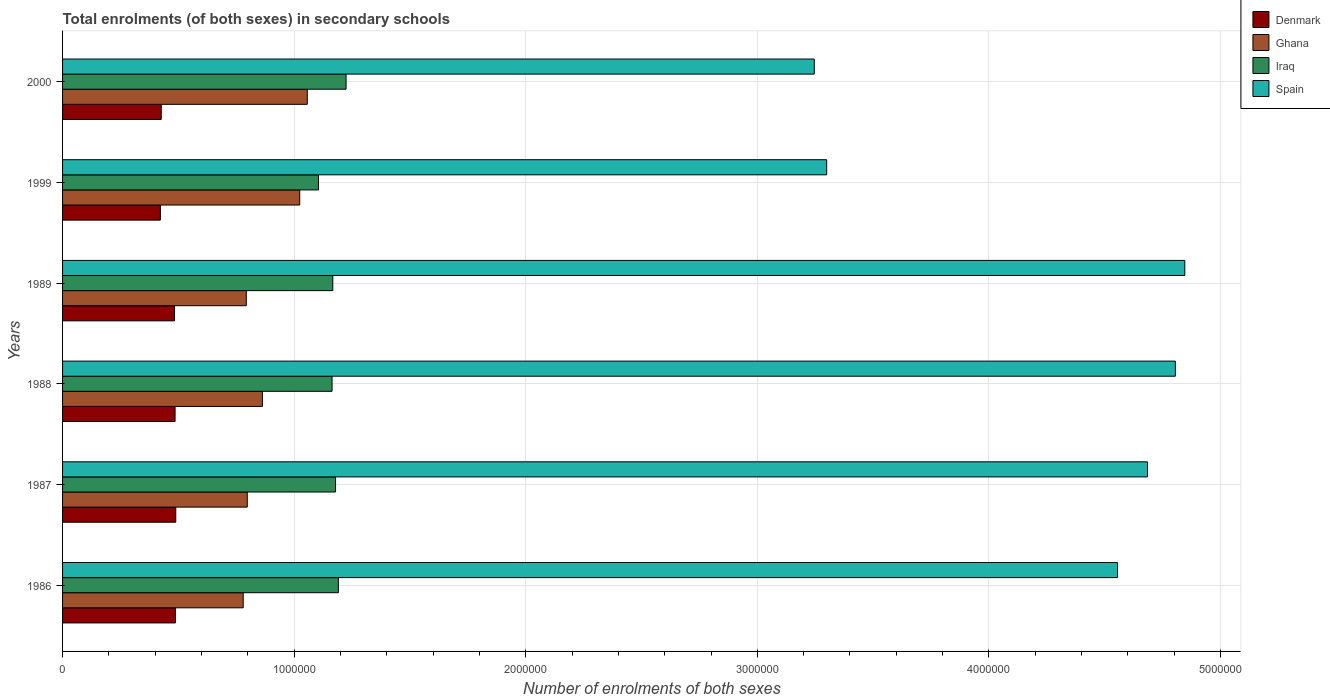Are the number of bars per tick equal to the number of legend labels?
Your answer should be compact. Yes. Are the number of bars on each tick of the Y-axis equal?
Offer a very short reply. Yes. In how many cases, is the number of bars for a given year not equal to the number of legend labels?
Offer a very short reply. 0. What is the number of enrolments in secondary schools in Iraq in 1987?
Keep it short and to the point. 1.18e+06. Across all years, what is the maximum number of enrolments in secondary schools in Spain?
Offer a very short reply. 4.85e+06. Across all years, what is the minimum number of enrolments in secondary schools in Denmark?
Offer a terse response. 4.22e+05. In which year was the number of enrolments in secondary schools in Denmark minimum?
Ensure brevity in your answer.  1999. What is the total number of enrolments in secondary schools in Iraq in the graph?
Ensure brevity in your answer.  7.03e+06. What is the difference between the number of enrolments in secondary schools in Iraq in 1986 and that in 1999?
Keep it short and to the point. 8.58e+04. What is the difference between the number of enrolments in secondary schools in Iraq in 1988 and the number of enrolments in secondary schools in Spain in 1989?
Offer a terse response. -3.68e+06. What is the average number of enrolments in secondary schools in Denmark per year?
Your response must be concise. 4.66e+05. In the year 1989, what is the difference between the number of enrolments in secondary schools in Denmark and number of enrolments in secondary schools in Iraq?
Make the answer very short. -6.83e+05. What is the ratio of the number of enrolments in secondary schools in Iraq in 1986 to that in 2000?
Provide a short and direct response. 0.97. Is the number of enrolments in secondary schools in Ghana in 1988 less than that in 1989?
Provide a succinct answer. No. What is the difference between the highest and the second highest number of enrolments in secondary schools in Spain?
Provide a short and direct response. 4.08e+04. What is the difference between the highest and the lowest number of enrolments in secondary schools in Ghana?
Give a very brief answer. 2.77e+05. In how many years, is the number of enrolments in secondary schools in Ghana greater than the average number of enrolments in secondary schools in Ghana taken over all years?
Ensure brevity in your answer.  2. Is the sum of the number of enrolments in secondary schools in Ghana in 1987 and 1988 greater than the maximum number of enrolments in secondary schools in Spain across all years?
Keep it short and to the point. No. Is it the case that in every year, the sum of the number of enrolments in secondary schools in Spain and number of enrolments in secondary schools in Ghana is greater than the sum of number of enrolments in secondary schools in Iraq and number of enrolments in secondary schools in Denmark?
Ensure brevity in your answer.  Yes. What does the 1st bar from the top in 1987 represents?
Make the answer very short. Spain. Is it the case that in every year, the sum of the number of enrolments in secondary schools in Denmark and number of enrolments in secondary schools in Iraq is greater than the number of enrolments in secondary schools in Spain?
Give a very brief answer. No. How many bars are there?
Give a very brief answer. 24. Are all the bars in the graph horizontal?
Provide a succinct answer. Yes. How many years are there in the graph?
Your answer should be very brief. 6. What is the difference between two consecutive major ticks on the X-axis?
Provide a short and direct response. 1.00e+06. Are the values on the major ticks of X-axis written in scientific E-notation?
Give a very brief answer. No. Does the graph contain grids?
Provide a short and direct response. Yes. What is the title of the graph?
Give a very brief answer. Total enrolments (of both sexes) in secondary schools. Does "East Asia (all income levels)" appear as one of the legend labels in the graph?
Offer a terse response. No. What is the label or title of the X-axis?
Give a very brief answer. Number of enrolments of both sexes. What is the Number of enrolments of both sexes of Denmark in 1986?
Offer a terse response. 4.88e+05. What is the Number of enrolments of both sexes of Ghana in 1986?
Your answer should be compact. 7.80e+05. What is the Number of enrolments of both sexes in Iraq in 1986?
Provide a short and direct response. 1.19e+06. What is the Number of enrolments of both sexes in Spain in 1986?
Give a very brief answer. 4.56e+06. What is the Number of enrolments of both sexes in Denmark in 1987?
Make the answer very short. 4.89e+05. What is the Number of enrolments of both sexes of Ghana in 1987?
Your response must be concise. 7.98e+05. What is the Number of enrolments of both sexes of Iraq in 1987?
Provide a succinct answer. 1.18e+06. What is the Number of enrolments of both sexes in Spain in 1987?
Your answer should be very brief. 4.68e+06. What is the Number of enrolments of both sexes of Denmark in 1988?
Give a very brief answer. 4.86e+05. What is the Number of enrolments of both sexes of Ghana in 1988?
Provide a short and direct response. 8.63e+05. What is the Number of enrolments of both sexes of Iraq in 1988?
Offer a terse response. 1.16e+06. What is the Number of enrolments of both sexes in Spain in 1988?
Your response must be concise. 4.81e+06. What is the Number of enrolments of both sexes in Denmark in 1989?
Make the answer very short. 4.84e+05. What is the Number of enrolments of both sexes in Ghana in 1989?
Offer a terse response. 7.93e+05. What is the Number of enrolments of both sexes in Iraq in 1989?
Your answer should be compact. 1.17e+06. What is the Number of enrolments of both sexes of Spain in 1989?
Provide a short and direct response. 4.85e+06. What is the Number of enrolments of both sexes of Denmark in 1999?
Provide a succinct answer. 4.22e+05. What is the Number of enrolments of both sexes in Ghana in 1999?
Make the answer very short. 1.02e+06. What is the Number of enrolments of both sexes in Iraq in 1999?
Your answer should be compact. 1.11e+06. What is the Number of enrolments of both sexes in Spain in 1999?
Provide a succinct answer. 3.30e+06. What is the Number of enrolments of both sexes of Denmark in 2000?
Ensure brevity in your answer.  4.26e+05. What is the Number of enrolments of both sexes of Ghana in 2000?
Your answer should be compact. 1.06e+06. What is the Number of enrolments of both sexes of Iraq in 2000?
Give a very brief answer. 1.22e+06. What is the Number of enrolments of both sexes in Spain in 2000?
Keep it short and to the point. 3.25e+06. Across all years, what is the maximum Number of enrolments of both sexes of Denmark?
Keep it short and to the point. 4.89e+05. Across all years, what is the maximum Number of enrolments of both sexes in Ghana?
Provide a short and direct response. 1.06e+06. Across all years, what is the maximum Number of enrolments of both sexes in Iraq?
Make the answer very short. 1.22e+06. Across all years, what is the maximum Number of enrolments of both sexes of Spain?
Offer a very short reply. 4.85e+06. Across all years, what is the minimum Number of enrolments of both sexes of Denmark?
Your answer should be very brief. 4.22e+05. Across all years, what is the minimum Number of enrolments of both sexes in Ghana?
Offer a very short reply. 7.80e+05. Across all years, what is the minimum Number of enrolments of both sexes in Iraq?
Give a very brief answer. 1.11e+06. Across all years, what is the minimum Number of enrolments of both sexes of Spain?
Provide a short and direct response. 3.25e+06. What is the total Number of enrolments of both sexes of Denmark in the graph?
Your response must be concise. 2.79e+06. What is the total Number of enrolments of both sexes of Ghana in the graph?
Provide a short and direct response. 5.31e+06. What is the total Number of enrolments of both sexes in Iraq in the graph?
Ensure brevity in your answer.  7.03e+06. What is the total Number of enrolments of both sexes in Spain in the graph?
Make the answer very short. 2.54e+07. What is the difference between the Number of enrolments of both sexes of Denmark in 1986 and that in 1987?
Make the answer very short. -1249. What is the difference between the Number of enrolments of both sexes of Ghana in 1986 and that in 1987?
Your response must be concise. -1.75e+04. What is the difference between the Number of enrolments of both sexes of Iraq in 1986 and that in 1987?
Ensure brevity in your answer.  1.21e+04. What is the difference between the Number of enrolments of both sexes in Spain in 1986 and that in 1987?
Offer a very short reply. -1.29e+05. What is the difference between the Number of enrolments of both sexes of Denmark in 1986 and that in 1988?
Provide a short and direct response. 1684. What is the difference between the Number of enrolments of both sexes in Ghana in 1986 and that in 1988?
Provide a short and direct response. -8.29e+04. What is the difference between the Number of enrolments of both sexes of Iraq in 1986 and that in 1988?
Provide a succinct answer. 2.71e+04. What is the difference between the Number of enrolments of both sexes in Spain in 1986 and that in 1988?
Provide a succinct answer. -2.50e+05. What is the difference between the Number of enrolments of both sexes of Denmark in 1986 and that in 1989?
Offer a terse response. 4024. What is the difference between the Number of enrolments of both sexes in Ghana in 1986 and that in 1989?
Ensure brevity in your answer.  -1.34e+04. What is the difference between the Number of enrolments of both sexes in Iraq in 1986 and that in 1989?
Ensure brevity in your answer.  2.40e+04. What is the difference between the Number of enrolments of both sexes in Spain in 1986 and that in 1989?
Provide a short and direct response. -2.90e+05. What is the difference between the Number of enrolments of both sexes in Denmark in 1986 and that in 1999?
Offer a terse response. 6.51e+04. What is the difference between the Number of enrolments of both sexes in Ghana in 1986 and that in 1999?
Ensure brevity in your answer.  -2.44e+05. What is the difference between the Number of enrolments of both sexes in Iraq in 1986 and that in 1999?
Your answer should be compact. 8.58e+04. What is the difference between the Number of enrolments of both sexes of Spain in 1986 and that in 1999?
Offer a terse response. 1.26e+06. What is the difference between the Number of enrolments of both sexes in Denmark in 1986 and that in 2000?
Provide a succinct answer. 6.14e+04. What is the difference between the Number of enrolments of both sexes of Ghana in 1986 and that in 2000?
Ensure brevity in your answer.  -2.77e+05. What is the difference between the Number of enrolments of both sexes in Iraq in 1986 and that in 2000?
Your answer should be compact. -3.34e+04. What is the difference between the Number of enrolments of both sexes of Spain in 1986 and that in 2000?
Ensure brevity in your answer.  1.31e+06. What is the difference between the Number of enrolments of both sexes of Denmark in 1987 and that in 1988?
Keep it short and to the point. 2933. What is the difference between the Number of enrolments of both sexes of Ghana in 1987 and that in 1988?
Keep it short and to the point. -6.54e+04. What is the difference between the Number of enrolments of both sexes of Iraq in 1987 and that in 1988?
Give a very brief answer. 1.51e+04. What is the difference between the Number of enrolments of both sexes in Spain in 1987 and that in 1988?
Your answer should be compact. -1.20e+05. What is the difference between the Number of enrolments of both sexes of Denmark in 1987 and that in 1989?
Keep it short and to the point. 5273. What is the difference between the Number of enrolments of both sexes in Ghana in 1987 and that in 1989?
Ensure brevity in your answer.  4140. What is the difference between the Number of enrolments of both sexes of Iraq in 1987 and that in 1989?
Give a very brief answer. 1.19e+04. What is the difference between the Number of enrolments of both sexes in Spain in 1987 and that in 1989?
Your answer should be very brief. -1.61e+05. What is the difference between the Number of enrolments of both sexes of Denmark in 1987 and that in 1999?
Ensure brevity in your answer.  6.64e+04. What is the difference between the Number of enrolments of both sexes of Ghana in 1987 and that in 1999?
Give a very brief answer. -2.27e+05. What is the difference between the Number of enrolments of both sexes of Iraq in 1987 and that in 1999?
Your answer should be very brief. 7.37e+04. What is the difference between the Number of enrolments of both sexes in Spain in 1987 and that in 1999?
Make the answer very short. 1.39e+06. What is the difference between the Number of enrolments of both sexes of Denmark in 1987 and that in 2000?
Your response must be concise. 6.26e+04. What is the difference between the Number of enrolments of both sexes in Ghana in 1987 and that in 2000?
Provide a short and direct response. -2.59e+05. What is the difference between the Number of enrolments of both sexes in Iraq in 1987 and that in 2000?
Give a very brief answer. -4.55e+04. What is the difference between the Number of enrolments of both sexes in Spain in 1987 and that in 2000?
Keep it short and to the point. 1.44e+06. What is the difference between the Number of enrolments of both sexes in Denmark in 1988 and that in 1989?
Offer a very short reply. 2340. What is the difference between the Number of enrolments of both sexes in Ghana in 1988 and that in 1989?
Offer a terse response. 6.95e+04. What is the difference between the Number of enrolments of both sexes in Iraq in 1988 and that in 1989?
Give a very brief answer. -3165. What is the difference between the Number of enrolments of both sexes in Spain in 1988 and that in 1989?
Offer a very short reply. -4.08e+04. What is the difference between the Number of enrolments of both sexes in Denmark in 1988 and that in 1999?
Your answer should be compact. 6.34e+04. What is the difference between the Number of enrolments of both sexes of Ghana in 1988 and that in 1999?
Offer a very short reply. -1.61e+05. What is the difference between the Number of enrolments of both sexes in Iraq in 1988 and that in 1999?
Make the answer very short. 5.87e+04. What is the difference between the Number of enrolments of both sexes of Spain in 1988 and that in 1999?
Provide a short and direct response. 1.51e+06. What is the difference between the Number of enrolments of both sexes of Denmark in 1988 and that in 2000?
Your response must be concise. 5.97e+04. What is the difference between the Number of enrolments of both sexes of Ghana in 1988 and that in 2000?
Keep it short and to the point. -1.94e+05. What is the difference between the Number of enrolments of both sexes of Iraq in 1988 and that in 2000?
Give a very brief answer. -6.06e+04. What is the difference between the Number of enrolments of both sexes of Spain in 1988 and that in 2000?
Provide a short and direct response. 1.56e+06. What is the difference between the Number of enrolments of both sexes in Denmark in 1989 and that in 1999?
Keep it short and to the point. 6.11e+04. What is the difference between the Number of enrolments of both sexes in Ghana in 1989 and that in 1999?
Make the answer very short. -2.31e+05. What is the difference between the Number of enrolments of both sexes in Iraq in 1989 and that in 1999?
Provide a short and direct response. 6.18e+04. What is the difference between the Number of enrolments of both sexes in Spain in 1989 and that in 1999?
Provide a short and direct response. 1.55e+06. What is the difference between the Number of enrolments of both sexes of Denmark in 1989 and that in 2000?
Provide a succinct answer. 5.74e+04. What is the difference between the Number of enrolments of both sexes in Ghana in 1989 and that in 2000?
Make the answer very short. -2.63e+05. What is the difference between the Number of enrolments of both sexes in Iraq in 1989 and that in 2000?
Make the answer very short. -5.74e+04. What is the difference between the Number of enrolments of both sexes of Spain in 1989 and that in 2000?
Ensure brevity in your answer.  1.60e+06. What is the difference between the Number of enrolments of both sexes in Denmark in 1999 and that in 2000?
Provide a short and direct response. -3750. What is the difference between the Number of enrolments of both sexes in Ghana in 1999 and that in 2000?
Offer a very short reply. -3.25e+04. What is the difference between the Number of enrolments of both sexes in Iraq in 1999 and that in 2000?
Ensure brevity in your answer.  -1.19e+05. What is the difference between the Number of enrolments of both sexes of Spain in 1999 and that in 2000?
Give a very brief answer. 5.35e+04. What is the difference between the Number of enrolments of both sexes of Denmark in 1986 and the Number of enrolments of both sexes of Ghana in 1987?
Ensure brevity in your answer.  -3.10e+05. What is the difference between the Number of enrolments of both sexes in Denmark in 1986 and the Number of enrolments of both sexes in Iraq in 1987?
Offer a terse response. -6.91e+05. What is the difference between the Number of enrolments of both sexes in Denmark in 1986 and the Number of enrolments of both sexes in Spain in 1987?
Provide a short and direct response. -4.20e+06. What is the difference between the Number of enrolments of both sexes in Ghana in 1986 and the Number of enrolments of both sexes in Iraq in 1987?
Make the answer very short. -3.99e+05. What is the difference between the Number of enrolments of both sexes of Ghana in 1986 and the Number of enrolments of both sexes of Spain in 1987?
Your response must be concise. -3.90e+06. What is the difference between the Number of enrolments of both sexes of Iraq in 1986 and the Number of enrolments of both sexes of Spain in 1987?
Provide a short and direct response. -3.49e+06. What is the difference between the Number of enrolments of both sexes in Denmark in 1986 and the Number of enrolments of both sexes in Ghana in 1988?
Your answer should be very brief. -3.75e+05. What is the difference between the Number of enrolments of both sexes of Denmark in 1986 and the Number of enrolments of both sexes of Iraq in 1988?
Your response must be concise. -6.76e+05. What is the difference between the Number of enrolments of both sexes in Denmark in 1986 and the Number of enrolments of both sexes in Spain in 1988?
Provide a succinct answer. -4.32e+06. What is the difference between the Number of enrolments of both sexes in Ghana in 1986 and the Number of enrolments of both sexes in Iraq in 1988?
Your answer should be very brief. -3.84e+05. What is the difference between the Number of enrolments of both sexes of Ghana in 1986 and the Number of enrolments of both sexes of Spain in 1988?
Your answer should be compact. -4.03e+06. What is the difference between the Number of enrolments of both sexes in Iraq in 1986 and the Number of enrolments of both sexes in Spain in 1988?
Your response must be concise. -3.61e+06. What is the difference between the Number of enrolments of both sexes of Denmark in 1986 and the Number of enrolments of both sexes of Ghana in 1989?
Your response must be concise. -3.06e+05. What is the difference between the Number of enrolments of both sexes in Denmark in 1986 and the Number of enrolments of both sexes in Iraq in 1989?
Your answer should be very brief. -6.79e+05. What is the difference between the Number of enrolments of both sexes in Denmark in 1986 and the Number of enrolments of both sexes in Spain in 1989?
Keep it short and to the point. -4.36e+06. What is the difference between the Number of enrolments of both sexes of Ghana in 1986 and the Number of enrolments of both sexes of Iraq in 1989?
Keep it short and to the point. -3.87e+05. What is the difference between the Number of enrolments of both sexes of Ghana in 1986 and the Number of enrolments of both sexes of Spain in 1989?
Offer a very short reply. -4.07e+06. What is the difference between the Number of enrolments of both sexes of Iraq in 1986 and the Number of enrolments of both sexes of Spain in 1989?
Make the answer very short. -3.66e+06. What is the difference between the Number of enrolments of both sexes in Denmark in 1986 and the Number of enrolments of both sexes in Ghana in 1999?
Offer a very short reply. -5.37e+05. What is the difference between the Number of enrolments of both sexes of Denmark in 1986 and the Number of enrolments of both sexes of Iraq in 1999?
Make the answer very short. -6.18e+05. What is the difference between the Number of enrolments of both sexes of Denmark in 1986 and the Number of enrolments of both sexes of Spain in 1999?
Offer a terse response. -2.81e+06. What is the difference between the Number of enrolments of both sexes of Ghana in 1986 and the Number of enrolments of both sexes of Iraq in 1999?
Your answer should be very brief. -3.25e+05. What is the difference between the Number of enrolments of both sexes in Ghana in 1986 and the Number of enrolments of both sexes in Spain in 1999?
Ensure brevity in your answer.  -2.52e+06. What is the difference between the Number of enrolments of both sexes in Iraq in 1986 and the Number of enrolments of both sexes in Spain in 1999?
Offer a very short reply. -2.11e+06. What is the difference between the Number of enrolments of both sexes of Denmark in 1986 and the Number of enrolments of both sexes of Ghana in 2000?
Give a very brief answer. -5.69e+05. What is the difference between the Number of enrolments of both sexes of Denmark in 1986 and the Number of enrolments of both sexes of Iraq in 2000?
Your answer should be very brief. -7.37e+05. What is the difference between the Number of enrolments of both sexes in Denmark in 1986 and the Number of enrolments of both sexes in Spain in 2000?
Give a very brief answer. -2.76e+06. What is the difference between the Number of enrolments of both sexes in Ghana in 1986 and the Number of enrolments of both sexes in Iraq in 2000?
Your response must be concise. -4.44e+05. What is the difference between the Number of enrolments of both sexes in Ghana in 1986 and the Number of enrolments of both sexes in Spain in 2000?
Provide a short and direct response. -2.47e+06. What is the difference between the Number of enrolments of both sexes of Iraq in 1986 and the Number of enrolments of both sexes of Spain in 2000?
Offer a terse response. -2.06e+06. What is the difference between the Number of enrolments of both sexes in Denmark in 1987 and the Number of enrolments of both sexes in Ghana in 1988?
Your response must be concise. -3.74e+05. What is the difference between the Number of enrolments of both sexes of Denmark in 1987 and the Number of enrolments of both sexes of Iraq in 1988?
Provide a succinct answer. -6.75e+05. What is the difference between the Number of enrolments of both sexes in Denmark in 1987 and the Number of enrolments of both sexes in Spain in 1988?
Make the answer very short. -4.32e+06. What is the difference between the Number of enrolments of both sexes of Ghana in 1987 and the Number of enrolments of both sexes of Iraq in 1988?
Your response must be concise. -3.66e+05. What is the difference between the Number of enrolments of both sexes in Ghana in 1987 and the Number of enrolments of both sexes in Spain in 1988?
Your answer should be compact. -4.01e+06. What is the difference between the Number of enrolments of both sexes of Iraq in 1987 and the Number of enrolments of both sexes of Spain in 1988?
Give a very brief answer. -3.63e+06. What is the difference between the Number of enrolments of both sexes in Denmark in 1987 and the Number of enrolments of both sexes in Ghana in 1989?
Make the answer very short. -3.05e+05. What is the difference between the Number of enrolments of both sexes in Denmark in 1987 and the Number of enrolments of both sexes in Iraq in 1989?
Your answer should be compact. -6.78e+05. What is the difference between the Number of enrolments of both sexes of Denmark in 1987 and the Number of enrolments of both sexes of Spain in 1989?
Keep it short and to the point. -4.36e+06. What is the difference between the Number of enrolments of both sexes of Ghana in 1987 and the Number of enrolments of both sexes of Iraq in 1989?
Offer a terse response. -3.69e+05. What is the difference between the Number of enrolments of both sexes in Ghana in 1987 and the Number of enrolments of both sexes in Spain in 1989?
Give a very brief answer. -4.05e+06. What is the difference between the Number of enrolments of both sexes in Iraq in 1987 and the Number of enrolments of both sexes in Spain in 1989?
Offer a terse response. -3.67e+06. What is the difference between the Number of enrolments of both sexes in Denmark in 1987 and the Number of enrolments of both sexes in Ghana in 1999?
Ensure brevity in your answer.  -5.35e+05. What is the difference between the Number of enrolments of both sexes in Denmark in 1987 and the Number of enrolments of both sexes in Iraq in 1999?
Your answer should be very brief. -6.16e+05. What is the difference between the Number of enrolments of both sexes in Denmark in 1987 and the Number of enrolments of both sexes in Spain in 1999?
Make the answer very short. -2.81e+06. What is the difference between the Number of enrolments of both sexes of Ghana in 1987 and the Number of enrolments of both sexes of Iraq in 1999?
Keep it short and to the point. -3.08e+05. What is the difference between the Number of enrolments of both sexes of Ghana in 1987 and the Number of enrolments of both sexes of Spain in 1999?
Offer a very short reply. -2.50e+06. What is the difference between the Number of enrolments of both sexes of Iraq in 1987 and the Number of enrolments of both sexes of Spain in 1999?
Keep it short and to the point. -2.12e+06. What is the difference between the Number of enrolments of both sexes of Denmark in 1987 and the Number of enrolments of both sexes of Ghana in 2000?
Make the answer very short. -5.68e+05. What is the difference between the Number of enrolments of both sexes of Denmark in 1987 and the Number of enrolments of both sexes of Iraq in 2000?
Your answer should be very brief. -7.35e+05. What is the difference between the Number of enrolments of both sexes in Denmark in 1987 and the Number of enrolments of both sexes in Spain in 2000?
Your answer should be compact. -2.76e+06. What is the difference between the Number of enrolments of both sexes in Ghana in 1987 and the Number of enrolments of both sexes in Iraq in 2000?
Provide a short and direct response. -4.27e+05. What is the difference between the Number of enrolments of both sexes in Ghana in 1987 and the Number of enrolments of both sexes in Spain in 2000?
Your response must be concise. -2.45e+06. What is the difference between the Number of enrolments of both sexes of Iraq in 1987 and the Number of enrolments of both sexes of Spain in 2000?
Ensure brevity in your answer.  -2.07e+06. What is the difference between the Number of enrolments of both sexes in Denmark in 1988 and the Number of enrolments of both sexes in Ghana in 1989?
Keep it short and to the point. -3.08e+05. What is the difference between the Number of enrolments of both sexes in Denmark in 1988 and the Number of enrolments of both sexes in Iraq in 1989?
Make the answer very short. -6.81e+05. What is the difference between the Number of enrolments of both sexes in Denmark in 1988 and the Number of enrolments of both sexes in Spain in 1989?
Your answer should be compact. -4.36e+06. What is the difference between the Number of enrolments of both sexes in Ghana in 1988 and the Number of enrolments of both sexes in Iraq in 1989?
Offer a terse response. -3.04e+05. What is the difference between the Number of enrolments of both sexes of Ghana in 1988 and the Number of enrolments of both sexes of Spain in 1989?
Your response must be concise. -3.98e+06. What is the difference between the Number of enrolments of both sexes in Iraq in 1988 and the Number of enrolments of both sexes in Spain in 1989?
Ensure brevity in your answer.  -3.68e+06. What is the difference between the Number of enrolments of both sexes in Denmark in 1988 and the Number of enrolments of both sexes in Ghana in 1999?
Ensure brevity in your answer.  -5.38e+05. What is the difference between the Number of enrolments of both sexes in Denmark in 1988 and the Number of enrolments of both sexes in Iraq in 1999?
Provide a short and direct response. -6.19e+05. What is the difference between the Number of enrolments of both sexes in Denmark in 1988 and the Number of enrolments of both sexes in Spain in 1999?
Provide a succinct answer. -2.81e+06. What is the difference between the Number of enrolments of both sexes in Ghana in 1988 and the Number of enrolments of both sexes in Iraq in 1999?
Your answer should be very brief. -2.42e+05. What is the difference between the Number of enrolments of both sexes of Ghana in 1988 and the Number of enrolments of both sexes of Spain in 1999?
Provide a short and direct response. -2.44e+06. What is the difference between the Number of enrolments of both sexes of Iraq in 1988 and the Number of enrolments of both sexes of Spain in 1999?
Your response must be concise. -2.14e+06. What is the difference between the Number of enrolments of both sexes in Denmark in 1988 and the Number of enrolments of both sexes in Ghana in 2000?
Your answer should be very brief. -5.71e+05. What is the difference between the Number of enrolments of both sexes in Denmark in 1988 and the Number of enrolments of both sexes in Iraq in 2000?
Provide a succinct answer. -7.38e+05. What is the difference between the Number of enrolments of both sexes of Denmark in 1988 and the Number of enrolments of both sexes of Spain in 2000?
Your answer should be compact. -2.76e+06. What is the difference between the Number of enrolments of both sexes in Ghana in 1988 and the Number of enrolments of both sexes in Iraq in 2000?
Give a very brief answer. -3.61e+05. What is the difference between the Number of enrolments of both sexes in Ghana in 1988 and the Number of enrolments of both sexes in Spain in 2000?
Provide a succinct answer. -2.38e+06. What is the difference between the Number of enrolments of both sexes of Iraq in 1988 and the Number of enrolments of both sexes of Spain in 2000?
Keep it short and to the point. -2.08e+06. What is the difference between the Number of enrolments of both sexes in Denmark in 1989 and the Number of enrolments of both sexes in Ghana in 1999?
Provide a succinct answer. -5.41e+05. What is the difference between the Number of enrolments of both sexes in Denmark in 1989 and the Number of enrolments of both sexes in Iraq in 1999?
Keep it short and to the point. -6.22e+05. What is the difference between the Number of enrolments of both sexes of Denmark in 1989 and the Number of enrolments of both sexes of Spain in 1999?
Your response must be concise. -2.82e+06. What is the difference between the Number of enrolments of both sexes in Ghana in 1989 and the Number of enrolments of both sexes in Iraq in 1999?
Your answer should be compact. -3.12e+05. What is the difference between the Number of enrolments of both sexes in Ghana in 1989 and the Number of enrolments of both sexes in Spain in 1999?
Your answer should be very brief. -2.51e+06. What is the difference between the Number of enrolments of both sexes of Iraq in 1989 and the Number of enrolments of both sexes of Spain in 1999?
Keep it short and to the point. -2.13e+06. What is the difference between the Number of enrolments of both sexes of Denmark in 1989 and the Number of enrolments of both sexes of Ghana in 2000?
Give a very brief answer. -5.73e+05. What is the difference between the Number of enrolments of both sexes in Denmark in 1989 and the Number of enrolments of both sexes in Iraq in 2000?
Your answer should be compact. -7.41e+05. What is the difference between the Number of enrolments of both sexes of Denmark in 1989 and the Number of enrolments of both sexes of Spain in 2000?
Make the answer very short. -2.76e+06. What is the difference between the Number of enrolments of both sexes in Ghana in 1989 and the Number of enrolments of both sexes in Iraq in 2000?
Provide a succinct answer. -4.31e+05. What is the difference between the Number of enrolments of both sexes of Ghana in 1989 and the Number of enrolments of both sexes of Spain in 2000?
Provide a succinct answer. -2.45e+06. What is the difference between the Number of enrolments of both sexes of Iraq in 1989 and the Number of enrolments of both sexes of Spain in 2000?
Give a very brief answer. -2.08e+06. What is the difference between the Number of enrolments of both sexes of Denmark in 1999 and the Number of enrolments of both sexes of Ghana in 2000?
Ensure brevity in your answer.  -6.34e+05. What is the difference between the Number of enrolments of both sexes of Denmark in 1999 and the Number of enrolments of both sexes of Iraq in 2000?
Your response must be concise. -8.02e+05. What is the difference between the Number of enrolments of both sexes in Denmark in 1999 and the Number of enrolments of both sexes in Spain in 2000?
Offer a terse response. -2.82e+06. What is the difference between the Number of enrolments of both sexes in Ghana in 1999 and the Number of enrolments of both sexes in Iraq in 2000?
Provide a short and direct response. -2.00e+05. What is the difference between the Number of enrolments of both sexes in Ghana in 1999 and the Number of enrolments of both sexes in Spain in 2000?
Ensure brevity in your answer.  -2.22e+06. What is the difference between the Number of enrolments of both sexes of Iraq in 1999 and the Number of enrolments of both sexes of Spain in 2000?
Your answer should be very brief. -2.14e+06. What is the average Number of enrolments of both sexes in Denmark per year?
Offer a terse response. 4.66e+05. What is the average Number of enrolments of both sexes of Ghana per year?
Offer a terse response. 8.86e+05. What is the average Number of enrolments of both sexes in Iraq per year?
Provide a short and direct response. 1.17e+06. What is the average Number of enrolments of both sexes in Spain per year?
Your response must be concise. 4.24e+06. In the year 1986, what is the difference between the Number of enrolments of both sexes of Denmark and Number of enrolments of both sexes of Ghana?
Provide a short and direct response. -2.92e+05. In the year 1986, what is the difference between the Number of enrolments of both sexes in Denmark and Number of enrolments of both sexes in Iraq?
Offer a very short reply. -7.03e+05. In the year 1986, what is the difference between the Number of enrolments of both sexes of Denmark and Number of enrolments of both sexes of Spain?
Keep it short and to the point. -4.07e+06. In the year 1986, what is the difference between the Number of enrolments of both sexes in Ghana and Number of enrolments of both sexes in Iraq?
Your response must be concise. -4.11e+05. In the year 1986, what is the difference between the Number of enrolments of both sexes of Ghana and Number of enrolments of both sexes of Spain?
Your answer should be very brief. -3.78e+06. In the year 1986, what is the difference between the Number of enrolments of both sexes of Iraq and Number of enrolments of both sexes of Spain?
Your response must be concise. -3.36e+06. In the year 1987, what is the difference between the Number of enrolments of both sexes in Denmark and Number of enrolments of both sexes in Ghana?
Provide a succinct answer. -3.09e+05. In the year 1987, what is the difference between the Number of enrolments of both sexes in Denmark and Number of enrolments of both sexes in Iraq?
Make the answer very short. -6.90e+05. In the year 1987, what is the difference between the Number of enrolments of both sexes in Denmark and Number of enrolments of both sexes in Spain?
Provide a succinct answer. -4.20e+06. In the year 1987, what is the difference between the Number of enrolments of both sexes of Ghana and Number of enrolments of both sexes of Iraq?
Ensure brevity in your answer.  -3.81e+05. In the year 1987, what is the difference between the Number of enrolments of both sexes in Ghana and Number of enrolments of both sexes in Spain?
Ensure brevity in your answer.  -3.89e+06. In the year 1987, what is the difference between the Number of enrolments of both sexes of Iraq and Number of enrolments of both sexes of Spain?
Ensure brevity in your answer.  -3.51e+06. In the year 1988, what is the difference between the Number of enrolments of both sexes of Denmark and Number of enrolments of both sexes of Ghana?
Provide a short and direct response. -3.77e+05. In the year 1988, what is the difference between the Number of enrolments of both sexes of Denmark and Number of enrolments of both sexes of Iraq?
Your answer should be compact. -6.78e+05. In the year 1988, what is the difference between the Number of enrolments of both sexes of Denmark and Number of enrolments of both sexes of Spain?
Your answer should be compact. -4.32e+06. In the year 1988, what is the difference between the Number of enrolments of both sexes in Ghana and Number of enrolments of both sexes in Iraq?
Give a very brief answer. -3.01e+05. In the year 1988, what is the difference between the Number of enrolments of both sexes in Ghana and Number of enrolments of both sexes in Spain?
Ensure brevity in your answer.  -3.94e+06. In the year 1988, what is the difference between the Number of enrolments of both sexes of Iraq and Number of enrolments of both sexes of Spain?
Your answer should be very brief. -3.64e+06. In the year 1989, what is the difference between the Number of enrolments of both sexes in Denmark and Number of enrolments of both sexes in Ghana?
Keep it short and to the point. -3.10e+05. In the year 1989, what is the difference between the Number of enrolments of both sexes of Denmark and Number of enrolments of both sexes of Iraq?
Provide a short and direct response. -6.83e+05. In the year 1989, what is the difference between the Number of enrolments of both sexes of Denmark and Number of enrolments of both sexes of Spain?
Provide a succinct answer. -4.36e+06. In the year 1989, what is the difference between the Number of enrolments of both sexes of Ghana and Number of enrolments of both sexes of Iraq?
Provide a short and direct response. -3.73e+05. In the year 1989, what is the difference between the Number of enrolments of both sexes of Ghana and Number of enrolments of both sexes of Spain?
Give a very brief answer. -4.05e+06. In the year 1989, what is the difference between the Number of enrolments of both sexes in Iraq and Number of enrolments of both sexes in Spain?
Provide a short and direct response. -3.68e+06. In the year 1999, what is the difference between the Number of enrolments of both sexes in Denmark and Number of enrolments of both sexes in Ghana?
Offer a very short reply. -6.02e+05. In the year 1999, what is the difference between the Number of enrolments of both sexes of Denmark and Number of enrolments of both sexes of Iraq?
Make the answer very short. -6.83e+05. In the year 1999, what is the difference between the Number of enrolments of both sexes of Denmark and Number of enrolments of both sexes of Spain?
Provide a succinct answer. -2.88e+06. In the year 1999, what is the difference between the Number of enrolments of both sexes in Ghana and Number of enrolments of both sexes in Iraq?
Ensure brevity in your answer.  -8.09e+04. In the year 1999, what is the difference between the Number of enrolments of both sexes in Ghana and Number of enrolments of both sexes in Spain?
Offer a very short reply. -2.28e+06. In the year 1999, what is the difference between the Number of enrolments of both sexes in Iraq and Number of enrolments of both sexes in Spain?
Keep it short and to the point. -2.19e+06. In the year 2000, what is the difference between the Number of enrolments of both sexes in Denmark and Number of enrolments of both sexes in Ghana?
Keep it short and to the point. -6.30e+05. In the year 2000, what is the difference between the Number of enrolments of both sexes of Denmark and Number of enrolments of both sexes of Iraq?
Your answer should be very brief. -7.98e+05. In the year 2000, what is the difference between the Number of enrolments of both sexes in Denmark and Number of enrolments of both sexes in Spain?
Your response must be concise. -2.82e+06. In the year 2000, what is the difference between the Number of enrolments of both sexes in Ghana and Number of enrolments of both sexes in Iraq?
Your answer should be compact. -1.68e+05. In the year 2000, what is the difference between the Number of enrolments of both sexes in Ghana and Number of enrolments of both sexes in Spain?
Provide a succinct answer. -2.19e+06. In the year 2000, what is the difference between the Number of enrolments of both sexes in Iraq and Number of enrolments of both sexes in Spain?
Your response must be concise. -2.02e+06. What is the ratio of the Number of enrolments of both sexes in Denmark in 1986 to that in 1987?
Keep it short and to the point. 1. What is the ratio of the Number of enrolments of both sexes in Iraq in 1986 to that in 1987?
Your answer should be very brief. 1.01. What is the ratio of the Number of enrolments of both sexes in Spain in 1986 to that in 1987?
Your response must be concise. 0.97. What is the ratio of the Number of enrolments of both sexes of Ghana in 1986 to that in 1988?
Make the answer very short. 0.9. What is the ratio of the Number of enrolments of both sexes of Iraq in 1986 to that in 1988?
Keep it short and to the point. 1.02. What is the ratio of the Number of enrolments of both sexes of Spain in 1986 to that in 1988?
Give a very brief answer. 0.95. What is the ratio of the Number of enrolments of both sexes in Denmark in 1986 to that in 1989?
Your answer should be very brief. 1.01. What is the ratio of the Number of enrolments of both sexes in Ghana in 1986 to that in 1989?
Ensure brevity in your answer.  0.98. What is the ratio of the Number of enrolments of both sexes in Iraq in 1986 to that in 1989?
Offer a terse response. 1.02. What is the ratio of the Number of enrolments of both sexes of Spain in 1986 to that in 1989?
Ensure brevity in your answer.  0.94. What is the ratio of the Number of enrolments of both sexes of Denmark in 1986 to that in 1999?
Offer a very short reply. 1.15. What is the ratio of the Number of enrolments of both sexes in Ghana in 1986 to that in 1999?
Your answer should be very brief. 0.76. What is the ratio of the Number of enrolments of both sexes of Iraq in 1986 to that in 1999?
Keep it short and to the point. 1.08. What is the ratio of the Number of enrolments of both sexes of Spain in 1986 to that in 1999?
Your answer should be compact. 1.38. What is the ratio of the Number of enrolments of both sexes in Denmark in 1986 to that in 2000?
Provide a short and direct response. 1.14. What is the ratio of the Number of enrolments of both sexes of Ghana in 1986 to that in 2000?
Your answer should be compact. 0.74. What is the ratio of the Number of enrolments of both sexes in Iraq in 1986 to that in 2000?
Offer a terse response. 0.97. What is the ratio of the Number of enrolments of both sexes of Spain in 1986 to that in 2000?
Your answer should be very brief. 1.4. What is the ratio of the Number of enrolments of both sexes in Ghana in 1987 to that in 1988?
Your response must be concise. 0.92. What is the ratio of the Number of enrolments of both sexes in Iraq in 1987 to that in 1988?
Keep it short and to the point. 1.01. What is the ratio of the Number of enrolments of both sexes in Spain in 1987 to that in 1988?
Provide a short and direct response. 0.97. What is the ratio of the Number of enrolments of both sexes in Denmark in 1987 to that in 1989?
Your response must be concise. 1.01. What is the ratio of the Number of enrolments of both sexes of Ghana in 1987 to that in 1989?
Keep it short and to the point. 1.01. What is the ratio of the Number of enrolments of both sexes in Iraq in 1987 to that in 1989?
Offer a very short reply. 1.01. What is the ratio of the Number of enrolments of both sexes of Spain in 1987 to that in 1989?
Give a very brief answer. 0.97. What is the ratio of the Number of enrolments of both sexes of Denmark in 1987 to that in 1999?
Give a very brief answer. 1.16. What is the ratio of the Number of enrolments of both sexes of Ghana in 1987 to that in 1999?
Offer a terse response. 0.78. What is the ratio of the Number of enrolments of both sexes in Iraq in 1987 to that in 1999?
Make the answer very short. 1.07. What is the ratio of the Number of enrolments of both sexes of Spain in 1987 to that in 1999?
Keep it short and to the point. 1.42. What is the ratio of the Number of enrolments of both sexes of Denmark in 1987 to that in 2000?
Your response must be concise. 1.15. What is the ratio of the Number of enrolments of both sexes in Ghana in 1987 to that in 2000?
Your response must be concise. 0.75. What is the ratio of the Number of enrolments of both sexes in Iraq in 1987 to that in 2000?
Provide a short and direct response. 0.96. What is the ratio of the Number of enrolments of both sexes in Spain in 1987 to that in 2000?
Ensure brevity in your answer.  1.44. What is the ratio of the Number of enrolments of both sexes in Ghana in 1988 to that in 1989?
Your answer should be compact. 1.09. What is the ratio of the Number of enrolments of both sexes in Iraq in 1988 to that in 1989?
Keep it short and to the point. 1. What is the ratio of the Number of enrolments of both sexes of Spain in 1988 to that in 1989?
Ensure brevity in your answer.  0.99. What is the ratio of the Number of enrolments of both sexes of Denmark in 1988 to that in 1999?
Your response must be concise. 1.15. What is the ratio of the Number of enrolments of both sexes in Ghana in 1988 to that in 1999?
Offer a terse response. 0.84. What is the ratio of the Number of enrolments of both sexes in Iraq in 1988 to that in 1999?
Offer a very short reply. 1.05. What is the ratio of the Number of enrolments of both sexes in Spain in 1988 to that in 1999?
Ensure brevity in your answer.  1.46. What is the ratio of the Number of enrolments of both sexes in Denmark in 1988 to that in 2000?
Give a very brief answer. 1.14. What is the ratio of the Number of enrolments of both sexes in Ghana in 1988 to that in 2000?
Make the answer very short. 0.82. What is the ratio of the Number of enrolments of both sexes of Iraq in 1988 to that in 2000?
Your response must be concise. 0.95. What is the ratio of the Number of enrolments of both sexes in Spain in 1988 to that in 2000?
Your answer should be compact. 1.48. What is the ratio of the Number of enrolments of both sexes in Denmark in 1989 to that in 1999?
Offer a very short reply. 1.14. What is the ratio of the Number of enrolments of both sexes of Ghana in 1989 to that in 1999?
Give a very brief answer. 0.77. What is the ratio of the Number of enrolments of both sexes of Iraq in 1989 to that in 1999?
Offer a terse response. 1.06. What is the ratio of the Number of enrolments of both sexes in Spain in 1989 to that in 1999?
Keep it short and to the point. 1.47. What is the ratio of the Number of enrolments of both sexes of Denmark in 1989 to that in 2000?
Offer a terse response. 1.13. What is the ratio of the Number of enrolments of both sexes in Ghana in 1989 to that in 2000?
Your response must be concise. 0.75. What is the ratio of the Number of enrolments of both sexes in Iraq in 1989 to that in 2000?
Make the answer very short. 0.95. What is the ratio of the Number of enrolments of both sexes of Spain in 1989 to that in 2000?
Keep it short and to the point. 1.49. What is the ratio of the Number of enrolments of both sexes of Denmark in 1999 to that in 2000?
Provide a succinct answer. 0.99. What is the ratio of the Number of enrolments of both sexes of Ghana in 1999 to that in 2000?
Your response must be concise. 0.97. What is the ratio of the Number of enrolments of both sexes of Iraq in 1999 to that in 2000?
Provide a succinct answer. 0.9. What is the ratio of the Number of enrolments of both sexes of Spain in 1999 to that in 2000?
Give a very brief answer. 1.02. What is the difference between the highest and the second highest Number of enrolments of both sexes of Denmark?
Provide a short and direct response. 1249. What is the difference between the highest and the second highest Number of enrolments of both sexes in Ghana?
Your response must be concise. 3.25e+04. What is the difference between the highest and the second highest Number of enrolments of both sexes of Iraq?
Offer a very short reply. 3.34e+04. What is the difference between the highest and the second highest Number of enrolments of both sexes in Spain?
Offer a very short reply. 4.08e+04. What is the difference between the highest and the lowest Number of enrolments of both sexes of Denmark?
Offer a terse response. 6.64e+04. What is the difference between the highest and the lowest Number of enrolments of both sexes of Ghana?
Your answer should be compact. 2.77e+05. What is the difference between the highest and the lowest Number of enrolments of both sexes in Iraq?
Offer a very short reply. 1.19e+05. What is the difference between the highest and the lowest Number of enrolments of both sexes of Spain?
Provide a succinct answer. 1.60e+06. 